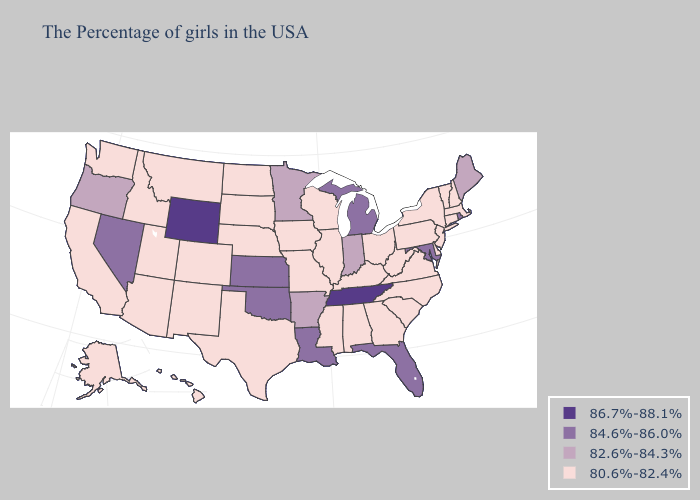Does Tennessee have the highest value in the USA?
Quick response, please. Yes. What is the lowest value in the Northeast?
Short answer required. 80.6%-82.4%. What is the lowest value in states that border Mississippi?
Answer briefly. 80.6%-82.4%. What is the value of New Mexico?
Answer briefly. 80.6%-82.4%. Name the states that have a value in the range 82.6%-84.3%?
Answer briefly. Maine, Indiana, Arkansas, Minnesota, Oregon. Does Wyoming have the highest value in the USA?
Keep it brief. Yes. Among the states that border Alabama , which have the highest value?
Concise answer only. Tennessee. Name the states that have a value in the range 80.6%-82.4%?
Answer briefly. Massachusetts, New Hampshire, Vermont, Connecticut, New York, New Jersey, Delaware, Pennsylvania, Virginia, North Carolina, South Carolina, West Virginia, Ohio, Georgia, Kentucky, Alabama, Wisconsin, Illinois, Mississippi, Missouri, Iowa, Nebraska, Texas, South Dakota, North Dakota, Colorado, New Mexico, Utah, Montana, Arizona, Idaho, California, Washington, Alaska, Hawaii. Does West Virginia have the lowest value in the USA?
Short answer required. Yes. Name the states that have a value in the range 82.6%-84.3%?
Keep it brief. Maine, Indiana, Arkansas, Minnesota, Oregon. Name the states that have a value in the range 84.6%-86.0%?
Answer briefly. Rhode Island, Maryland, Florida, Michigan, Louisiana, Kansas, Oklahoma, Nevada. Does Oklahoma have the lowest value in the South?
Answer briefly. No. Does Pennsylvania have the lowest value in the USA?
Quick response, please. Yes. Name the states that have a value in the range 84.6%-86.0%?
Answer briefly. Rhode Island, Maryland, Florida, Michigan, Louisiana, Kansas, Oklahoma, Nevada. 